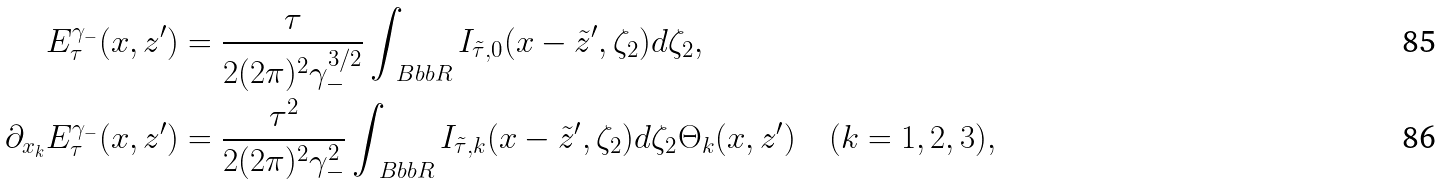Convert formula to latex. <formula><loc_0><loc_0><loc_500><loc_500>E ^ { \gamma _ { - } } _ { \tau } ( x , z ^ { \prime } ) & = \frac { \tau } { 2 ( 2 \pi ) ^ { 2 } \gamma _ { - } ^ { 3 / 2 } } \int _ { \ B b b R } I _ { \tilde { \tau } , 0 } ( x - \tilde { z } ^ { \prime } , \zeta _ { 2 } ) d \zeta _ { 2 } , \\ \partial _ { x _ { k } } E ^ { \gamma _ { - } } _ { \tau } ( x , z ^ { \prime } ) & = \frac { \tau ^ { 2 } } { 2 ( 2 \pi ) ^ { 2 } \gamma _ { - } ^ { 2 } } \int _ { \ B b b R } I _ { \tilde { \tau } , k } ( x - \tilde { z } ^ { \prime } , \zeta _ { 2 } ) d \zeta _ { 2 } \Theta _ { k } ( x , z ^ { \prime } ) \quad ( k = 1 , 2 , 3 ) ,</formula> 